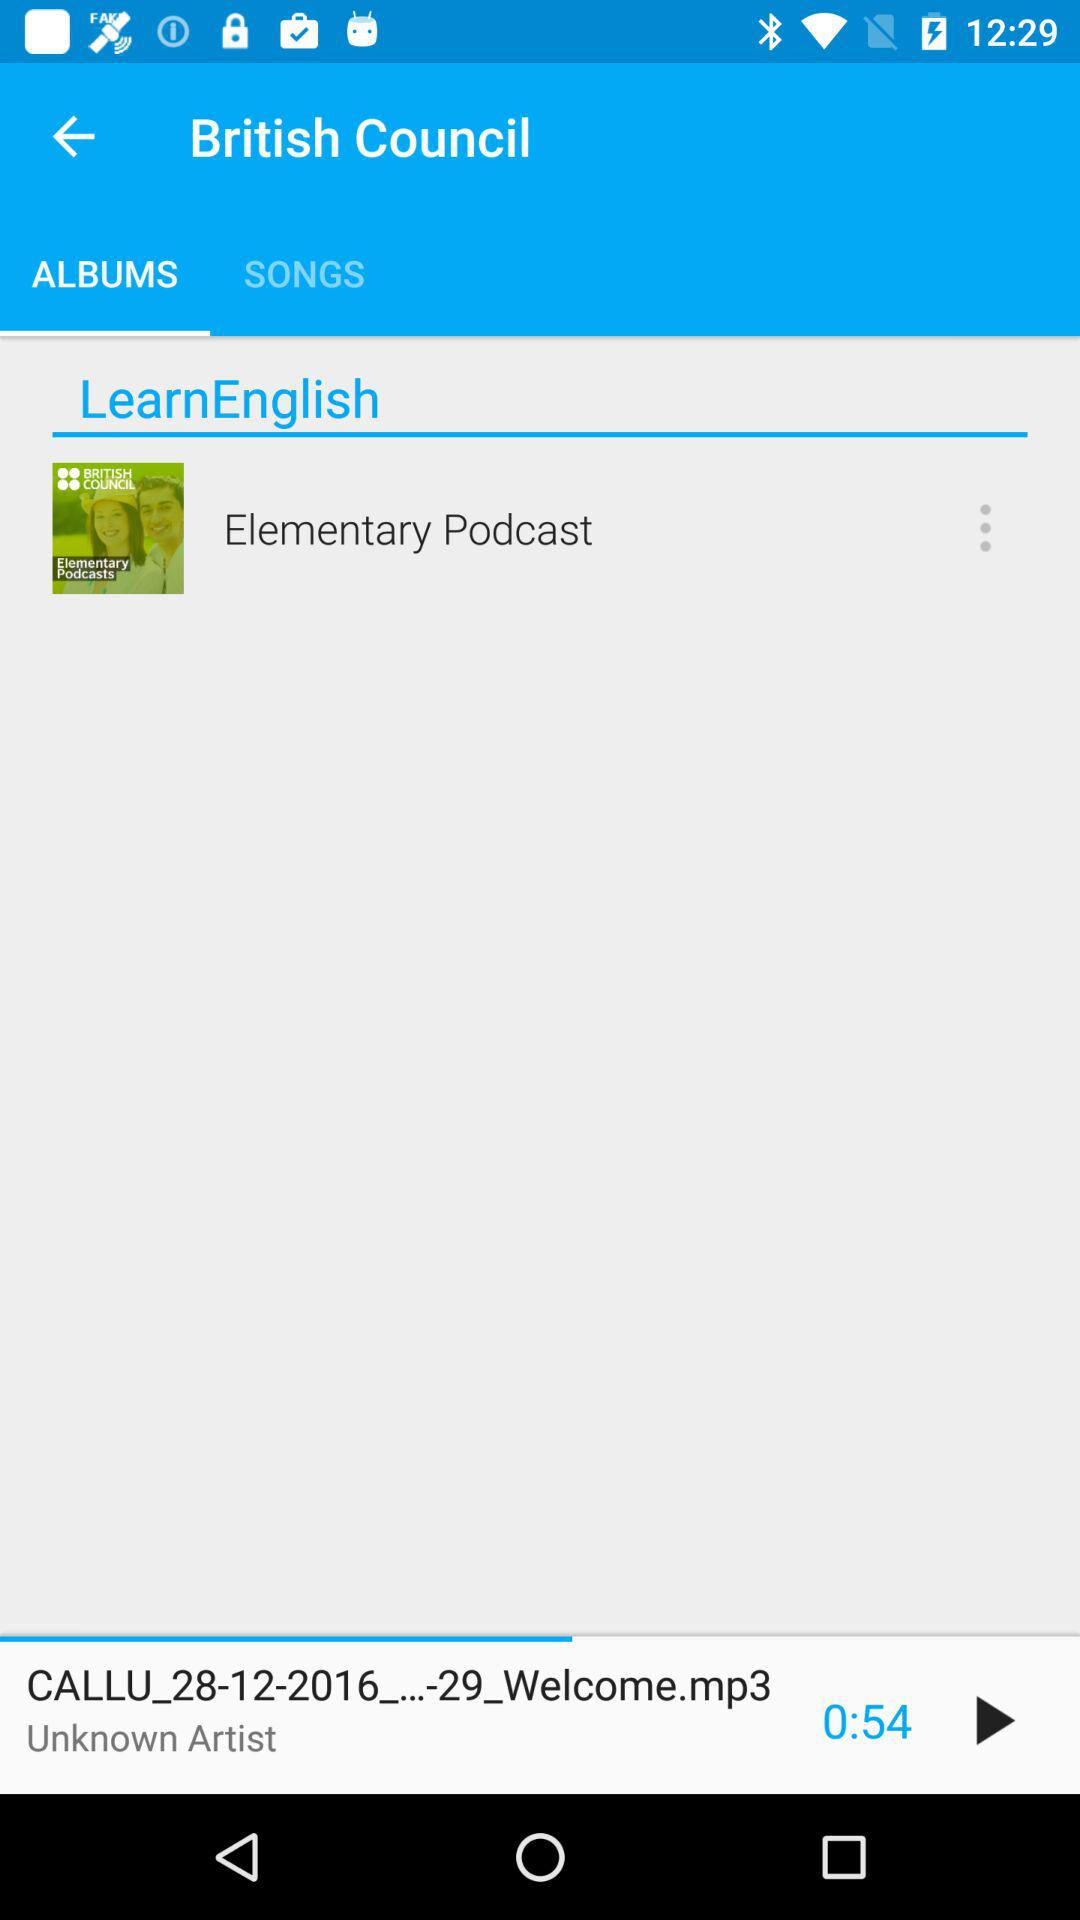Which tab am I on? You are on the "ALBUMS" tab. 